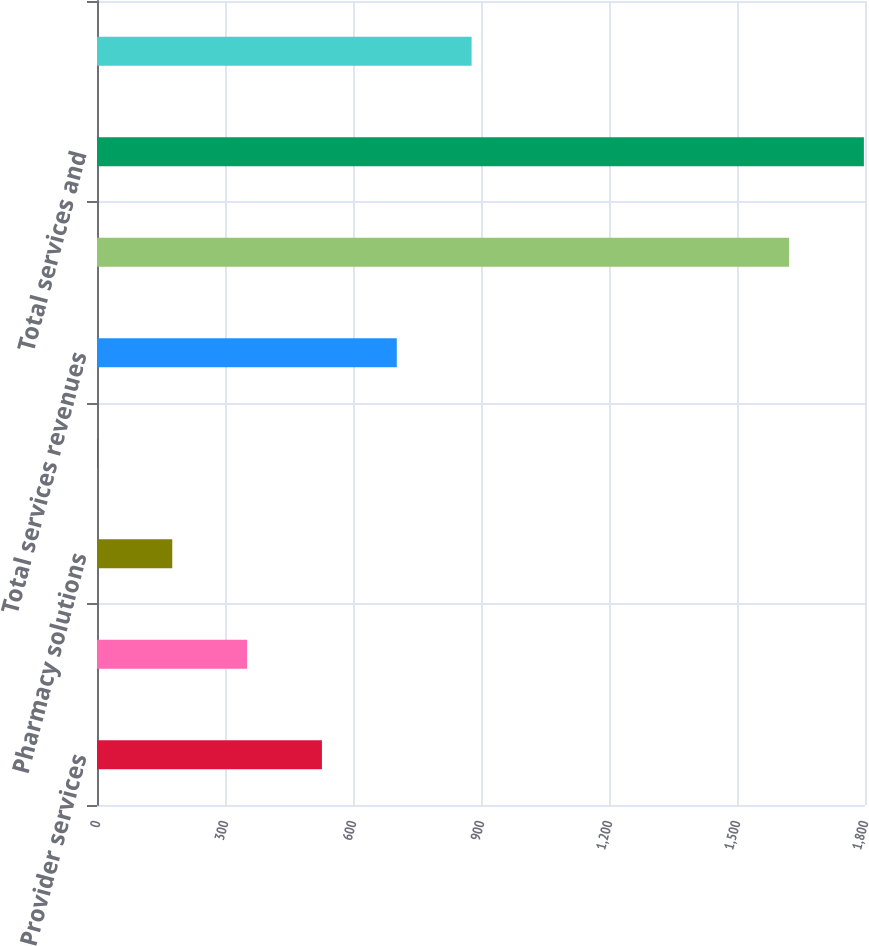Convert chart. <chart><loc_0><loc_0><loc_500><loc_500><bar_chart><fcel>Provider services<fcel>Home care services<fcel>Pharmacy solutions<fcel>Integrated wellness services<fcel>Total services revenues<fcel>Total intersegment revenues<fcel>Total services and<fcel>Income before income taxes<nl><fcel>527.2<fcel>351.8<fcel>176.4<fcel>1<fcel>702.6<fcel>1622<fcel>1797.4<fcel>878<nl></chart> 